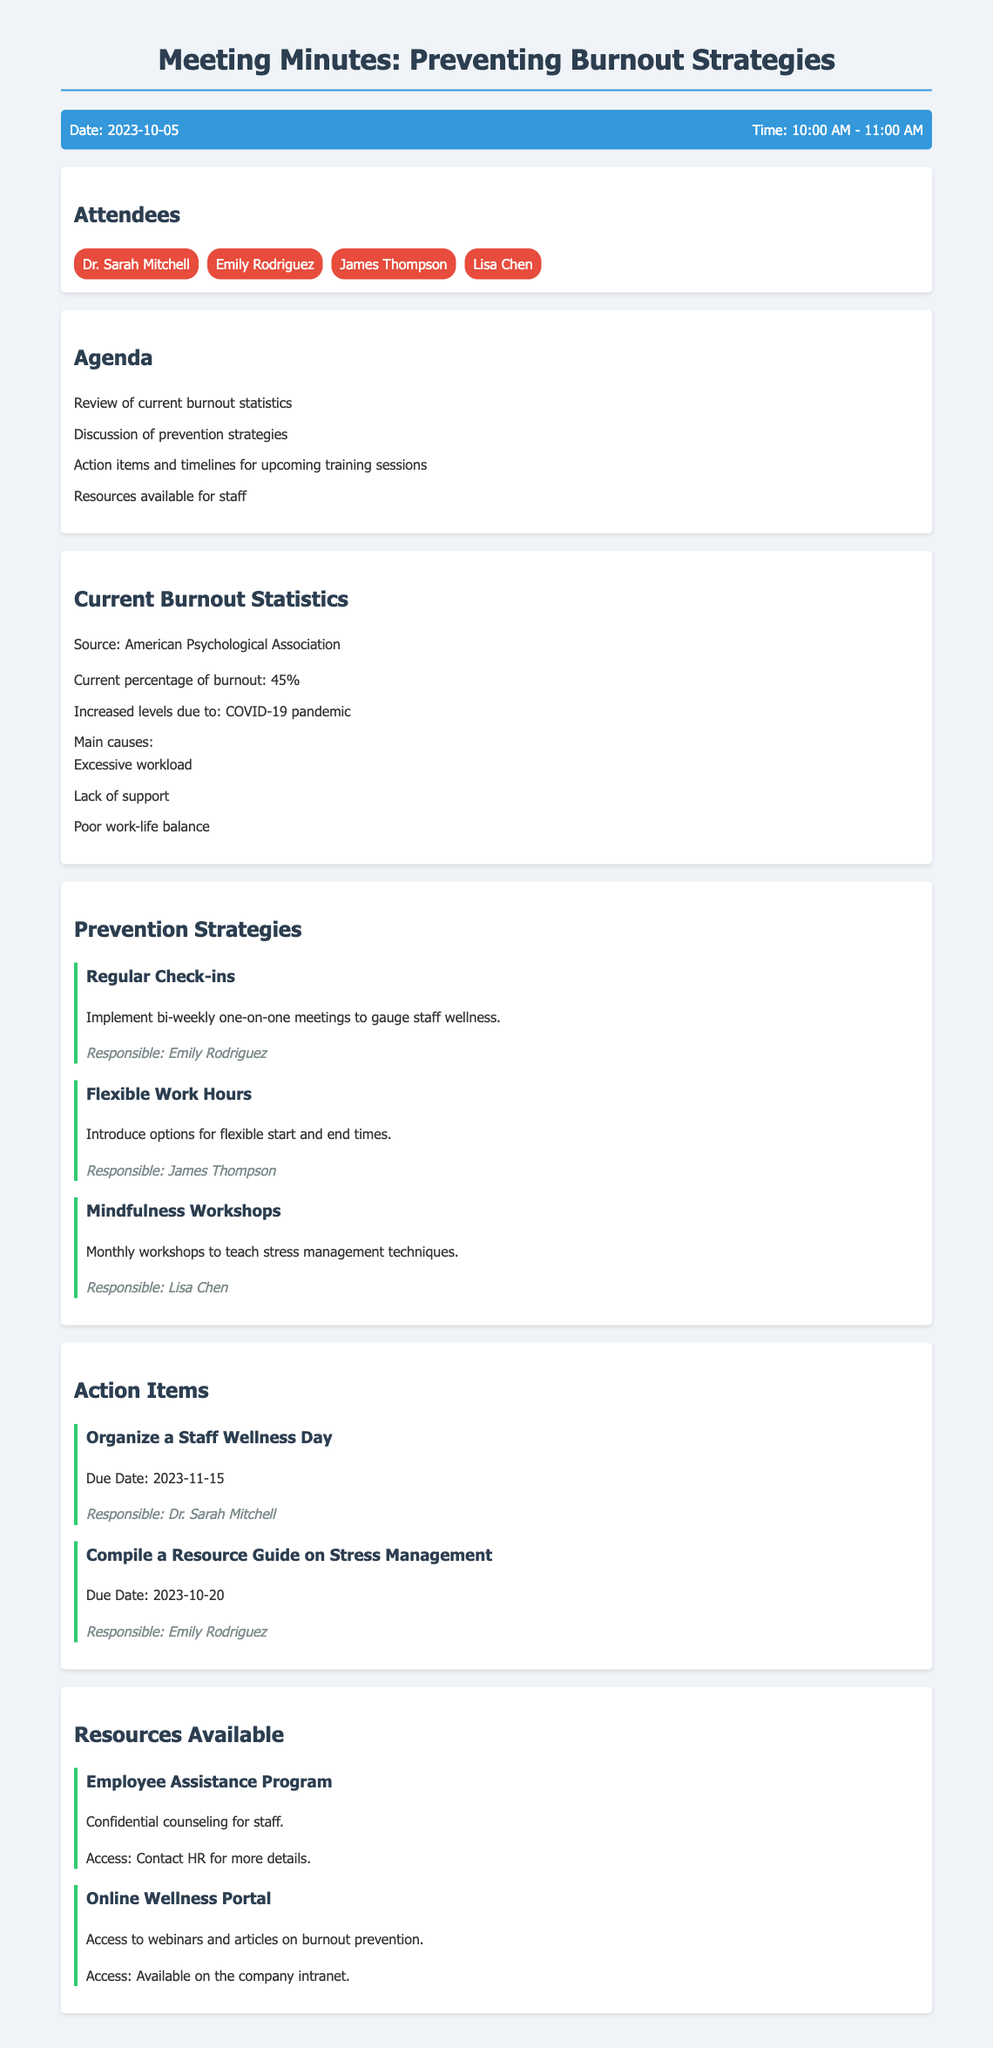What date was the meeting held? The meeting date is stated at the top of the document under the header information.
Answer: 2023-10-05 Who is responsible for organizing the Staff Wellness Day? The responsibility for this task is mentioned under the action items section.
Answer: Dr. Sarah Mitchell What percentage of burnout is currently reported? This statistic is mentioned during the review of current burnout statistics.
Answer: 45% What is one of the main causes of burnout listed in the document? The document lists the main causes under the current burnout statistics section.
Answer: Excessive workload When is the resource guide on stress management due? The due date for this action item is specified in the action items section.
Answer: 2023-10-20 What type of workshops are being planned monthly? The type of workshops is mentioned in the prevention strategies section.
Answer: Mindfulness Workshops How can staff access the Employee Assistance Program? The method of access for this resource is mentioned in the resources section.
Answer: Contact HR for more details What is the purpose of the regular check-ins strategy? The purpose of the regular check-ins is described in the prevention strategies section.
Answer: Gauge staff wellness 